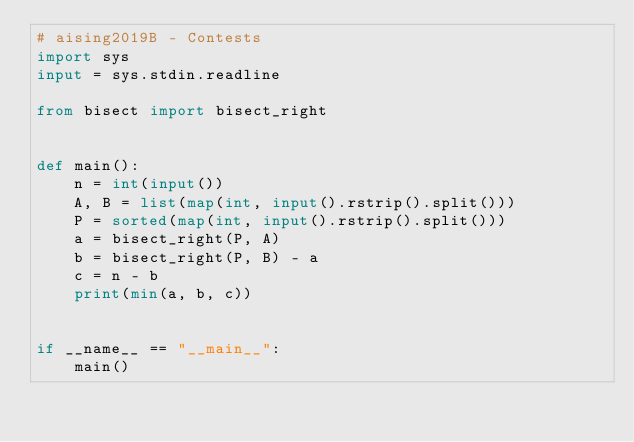Convert code to text. <code><loc_0><loc_0><loc_500><loc_500><_Python_># aising2019B - Contests
import sys
input = sys.stdin.readline

from bisect import bisect_right


def main():
    n = int(input())
    A, B = list(map(int, input().rstrip().split()))
    P = sorted(map(int, input().rstrip().split()))
    a = bisect_right(P, A)
    b = bisect_right(P, B) - a
    c = n - b
    print(min(a, b, c))


if __name__ == "__main__":
    main()</code> 